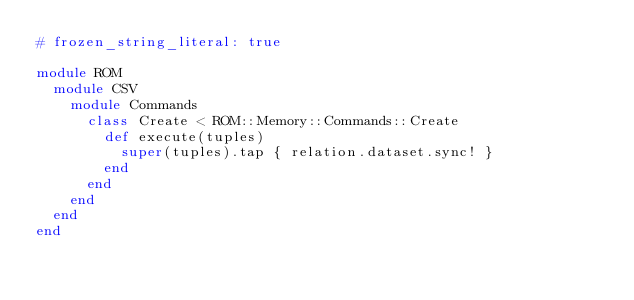<code> <loc_0><loc_0><loc_500><loc_500><_Ruby_># frozen_string_literal: true

module ROM
  module CSV
    module Commands
      class Create < ROM::Memory::Commands::Create
        def execute(tuples)
          super(tuples).tap { relation.dataset.sync! }
        end
      end
    end
  end
end
</code> 